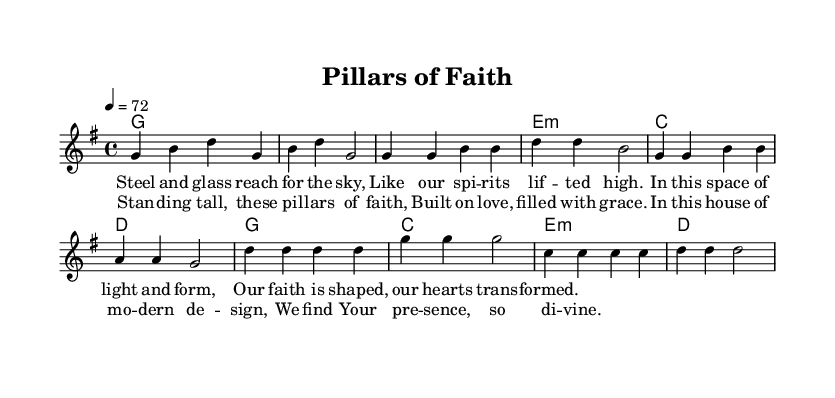What is the key signature of this music? The key signature indicates that the piece is in G major, which has one sharp (F#). This can be identified at the beginning of the staff, where the key signature symbols are placed.
Answer: G major What is the time signature of this music? The time signature is located right after the key signature at the beginning of the music. It shows a 4/4 time signature, which means there are four beats in each measure and a quarter note receives one beat.
Answer: 4/4 What is the tempo marking of this piece? The tempo marking can be found at the beginning of the score, stating the beats per minute. Here, it indicates a tempo of 72, meaning there should be 72 beats in one minute.
Answer: 72 How many measures are in the chorus section? By looking at the chorus section, we can count the measures within that section. The chorus consists of four distinct measures as indicated by the vertical bars separating them.
Answer: 4 What is the main theme expressed in the lyrics? The lyrics express a theme of faith as represented by architectural imagery, specifically referencing "pillars of faith" and the divine presence in modern design. This theme connects religious concepts with contemporary architecture.
Answer: Faith and modern design How do the chords change throughout the verse? The chords progress in a specific sequence in the verse. They begin with G major, follow with E minor, then C major, and lastly D major. This pattern can be traced by observing the chord changes noted above the melody staff.
Answer: G, E minor, C, D What architectural features are referenced in the lyrics? The lyrics refer to "steel and glass" and "pillars,” both of which are common elements in modern architecture. These references help in visualizing the blend of faith and contemporary structure, emphasizing how the environment shapes the worship experience.
Answer: Steel and glass, pillars 